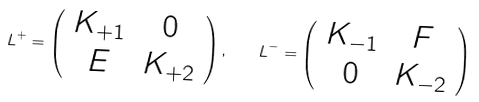Convert formula to latex. <formula><loc_0><loc_0><loc_500><loc_500>L ^ { + } = \left ( \begin{array} { c c } K _ { + 1 } & 0 \\ E & K _ { + 2 } \end{array} \right ) , \quad L ^ { - } = \left ( \begin{array} { c c } K _ { - 1 } & F \\ 0 & K _ { - 2 } \end{array} \right )</formula> 